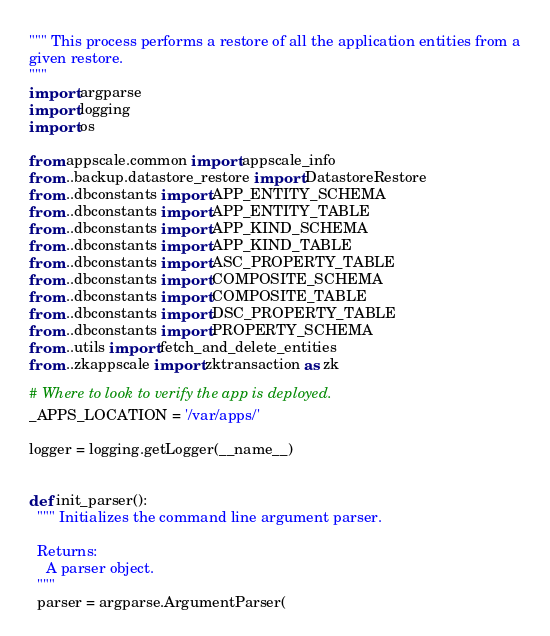Convert code to text. <code><loc_0><loc_0><loc_500><loc_500><_Python_>""" This process performs a restore of all the application entities from a
given restore.
"""
import argparse
import logging
import os

from appscale.common import appscale_info
from ..backup.datastore_restore import DatastoreRestore
from ..dbconstants import APP_ENTITY_SCHEMA
from ..dbconstants import APP_ENTITY_TABLE
from ..dbconstants import APP_KIND_SCHEMA
from ..dbconstants import APP_KIND_TABLE
from ..dbconstants import ASC_PROPERTY_TABLE
from ..dbconstants import COMPOSITE_SCHEMA
from ..dbconstants import COMPOSITE_TABLE
from ..dbconstants import DSC_PROPERTY_TABLE
from ..dbconstants import PROPERTY_SCHEMA
from ..utils import fetch_and_delete_entities
from ..zkappscale import zktransaction as zk

# Where to look to verify the app is deployed.
_APPS_LOCATION = '/var/apps/'

logger = logging.getLogger(__name__)


def init_parser():
  """ Initializes the command line argument parser.

  Returns:
    A parser object.
  """
  parser = argparse.ArgumentParser(</code> 